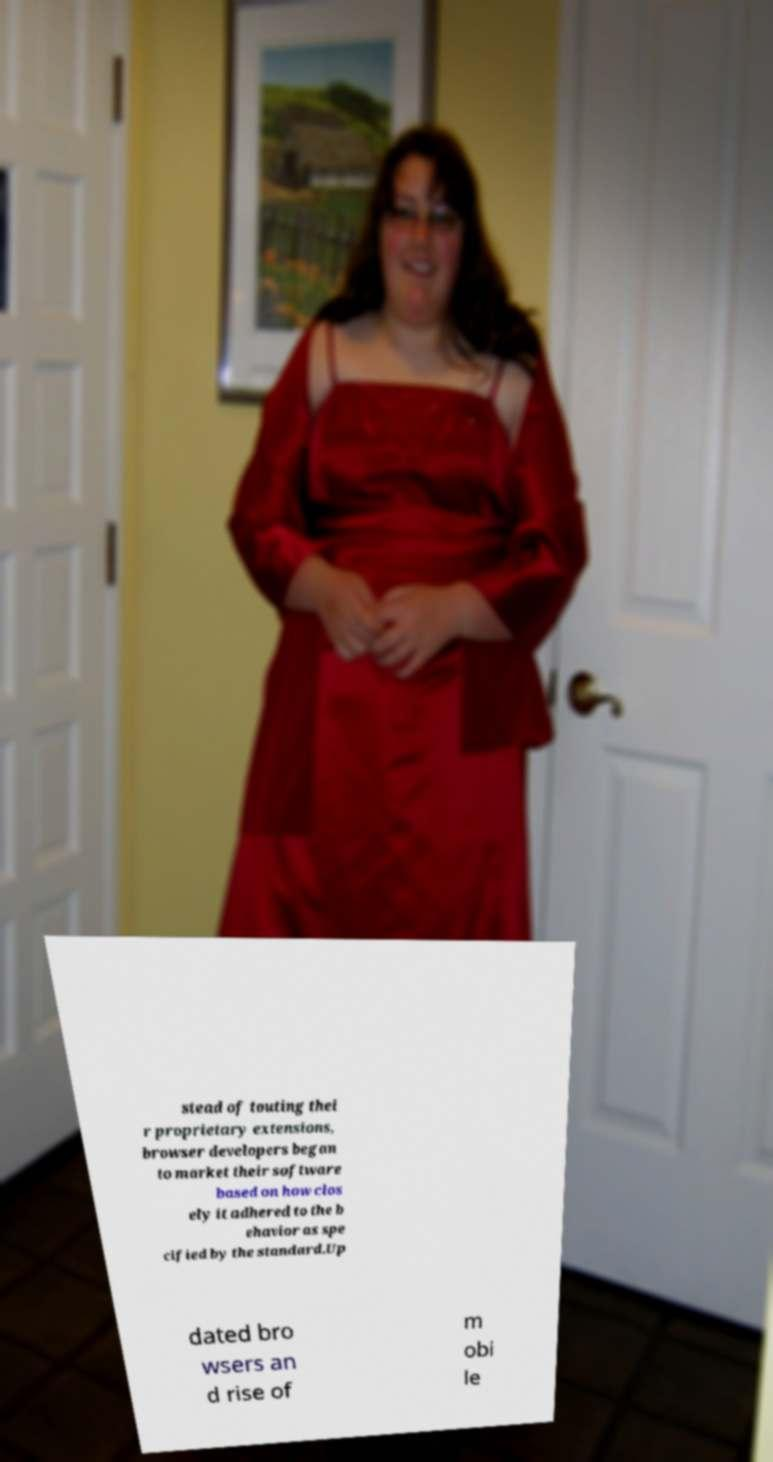There's text embedded in this image that I need extracted. Can you transcribe it verbatim? stead of touting thei r proprietary extensions, browser developers began to market their software based on how clos ely it adhered to the b ehavior as spe cified by the standard.Up dated bro wsers an d rise of m obi le 